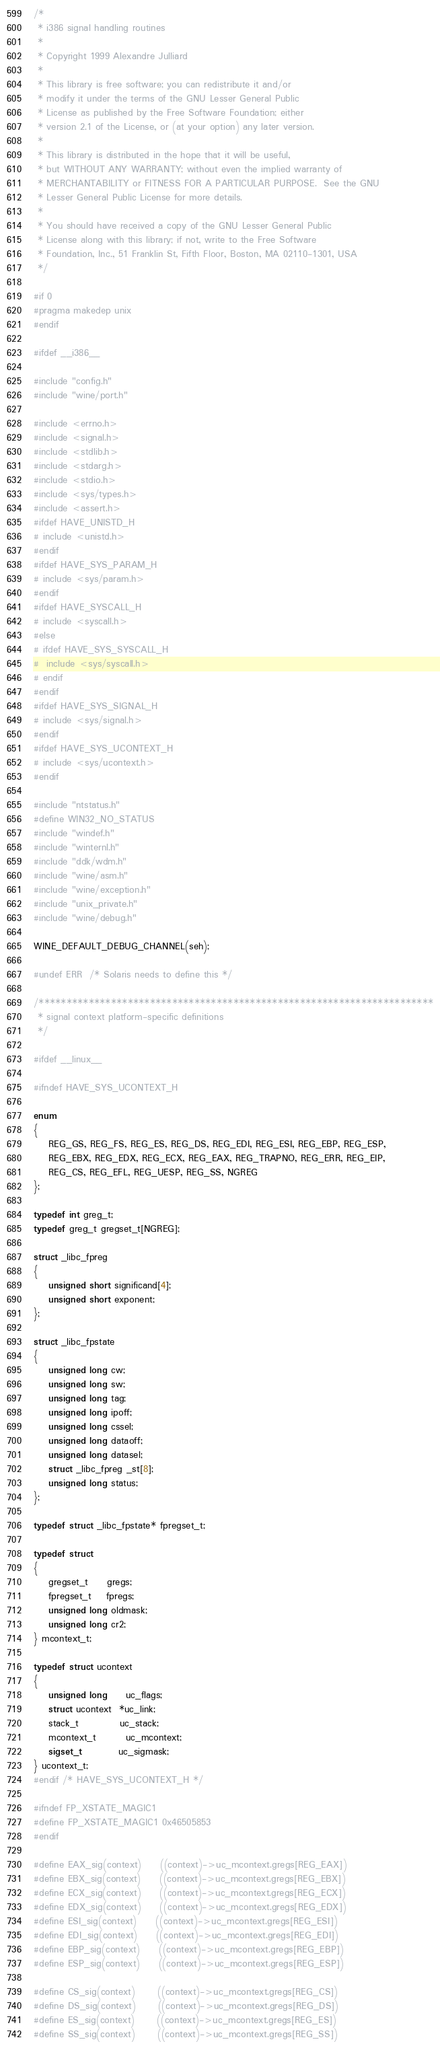Convert code to text. <code><loc_0><loc_0><loc_500><loc_500><_C_>/*
 * i386 signal handling routines
 *
 * Copyright 1999 Alexandre Julliard
 *
 * This library is free software; you can redistribute it and/or
 * modify it under the terms of the GNU Lesser General Public
 * License as published by the Free Software Foundation; either
 * version 2.1 of the License, or (at your option) any later version.
 *
 * This library is distributed in the hope that it will be useful,
 * but WITHOUT ANY WARRANTY; without even the implied warranty of
 * MERCHANTABILITY or FITNESS FOR A PARTICULAR PURPOSE.  See the GNU
 * Lesser General Public License for more details.
 *
 * You should have received a copy of the GNU Lesser General Public
 * License along with this library; if not, write to the Free Software
 * Foundation, Inc., 51 Franklin St, Fifth Floor, Boston, MA 02110-1301, USA
 */

#if 0
#pragma makedep unix
#endif

#ifdef __i386__

#include "config.h"
#include "wine/port.h"

#include <errno.h>
#include <signal.h>
#include <stdlib.h>
#include <stdarg.h>
#include <stdio.h>
#include <sys/types.h>
#include <assert.h>
#ifdef HAVE_UNISTD_H
# include <unistd.h>
#endif
#ifdef HAVE_SYS_PARAM_H
# include <sys/param.h>
#endif
#ifdef HAVE_SYSCALL_H
# include <syscall.h>
#else
# ifdef HAVE_SYS_SYSCALL_H
#  include <sys/syscall.h>
# endif
#endif
#ifdef HAVE_SYS_SIGNAL_H
# include <sys/signal.h>
#endif
#ifdef HAVE_SYS_UCONTEXT_H
# include <sys/ucontext.h>
#endif

#include "ntstatus.h"
#define WIN32_NO_STATUS
#include "windef.h"
#include "winternl.h"
#include "ddk/wdm.h"
#include "wine/asm.h"
#include "wine/exception.h"
#include "unix_private.h"
#include "wine/debug.h"

WINE_DEFAULT_DEBUG_CHANNEL(seh);

#undef ERR  /* Solaris needs to define this */

/***********************************************************************
 * signal context platform-specific definitions
 */

#ifdef __linux__

#ifndef HAVE_SYS_UCONTEXT_H

enum
{
    REG_GS, REG_FS, REG_ES, REG_DS, REG_EDI, REG_ESI, REG_EBP, REG_ESP,
    REG_EBX, REG_EDX, REG_ECX, REG_EAX, REG_TRAPNO, REG_ERR, REG_EIP,
    REG_CS, REG_EFL, REG_UESP, REG_SS, NGREG
};

typedef int greg_t;
typedef greg_t gregset_t[NGREG];

struct _libc_fpreg
{
    unsigned short significand[4];
    unsigned short exponent;
};

struct _libc_fpstate
{
    unsigned long cw;
    unsigned long sw;
    unsigned long tag;
    unsigned long ipoff;
    unsigned long cssel;
    unsigned long dataoff;
    unsigned long datasel;
    struct _libc_fpreg _st[8];
    unsigned long status;
};

typedef struct _libc_fpstate* fpregset_t;

typedef struct
{
    gregset_t     gregs;
    fpregset_t    fpregs;
    unsigned long oldmask;
    unsigned long cr2;
} mcontext_t;

typedef struct ucontext
{
    unsigned long     uc_flags;
    struct ucontext  *uc_link;
    stack_t           uc_stack;
    mcontext_t        uc_mcontext;
    sigset_t          uc_sigmask;
} ucontext_t;
#endif /* HAVE_SYS_UCONTEXT_H */

#ifndef FP_XSTATE_MAGIC1
#define FP_XSTATE_MAGIC1 0x46505853
#endif

#define EAX_sig(context)     ((context)->uc_mcontext.gregs[REG_EAX])
#define EBX_sig(context)     ((context)->uc_mcontext.gregs[REG_EBX])
#define ECX_sig(context)     ((context)->uc_mcontext.gregs[REG_ECX])
#define EDX_sig(context)     ((context)->uc_mcontext.gregs[REG_EDX])
#define ESI_sig(context)     ((context)->uc_mcontext.gregs[REG_ESI])
#define EDI_sig(context)     ((context)->uc_mcontext.gregs[REG_EDI])
#define EBP_sig(context)     ((context)->uc_mcontext.gregs[REG_EBP])
#define ESP_sig(context)     ((context)->uc_mcontext.gregs[REG_ESP])

#define CS_sig(context)      ((context)->uc_mcontext.gregs[REG_CS])
#define DS_sig(context)      ((context)->uc_mcontext.gregs[REG_DS])
#define ES_sig(context)      ((context)->uc_mcontext.gregs[REG_ES])
#define SS_sig(context)      ((context)->uc_mcontext.gregs[REG_SS])</code> 